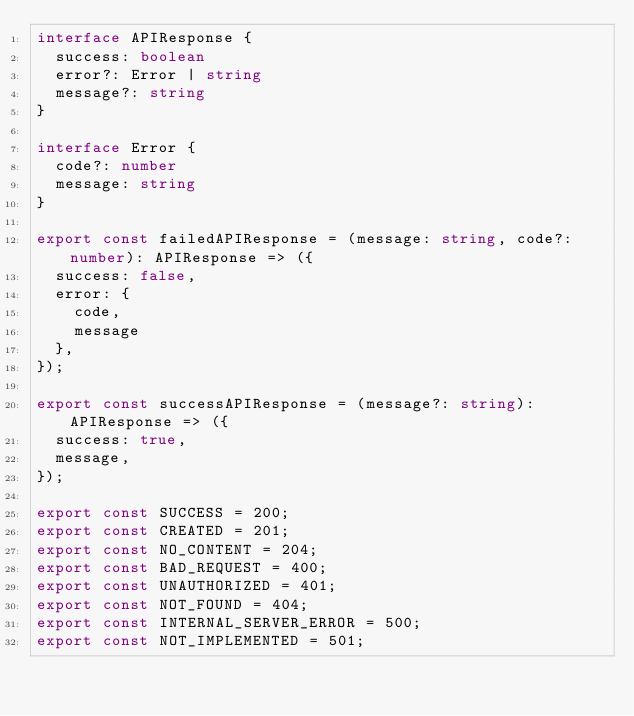<code> <loc_0><loc_0><loc_500><loc_500><_TypeScript_>interface APIResponse {
  success: boolean
  error?: Error | string
  message?: string
}

interface Error {
  code?: number
  message: string
}

export const failedAPIResponse = (message: string, code?: number): APIResponse => ({
  success: false,
  error: {
    code,
    message
  },
});

export const successAPIResponse = (message?: string): APIResponse => ({
  success: true,
  message,
});

export const SUCCESS = 200;
export const CREATED = 201;
export const NO_CONTENT = 204;
export const BAD_REQUEST = 400;
export const UNAUTHORIZED = 401;
export const NOT_FOUND = 404;
export const INTERNAL_SERVER_ERROR = 500;
export const NOT_IMPLEMENTED = 501;
</code> 